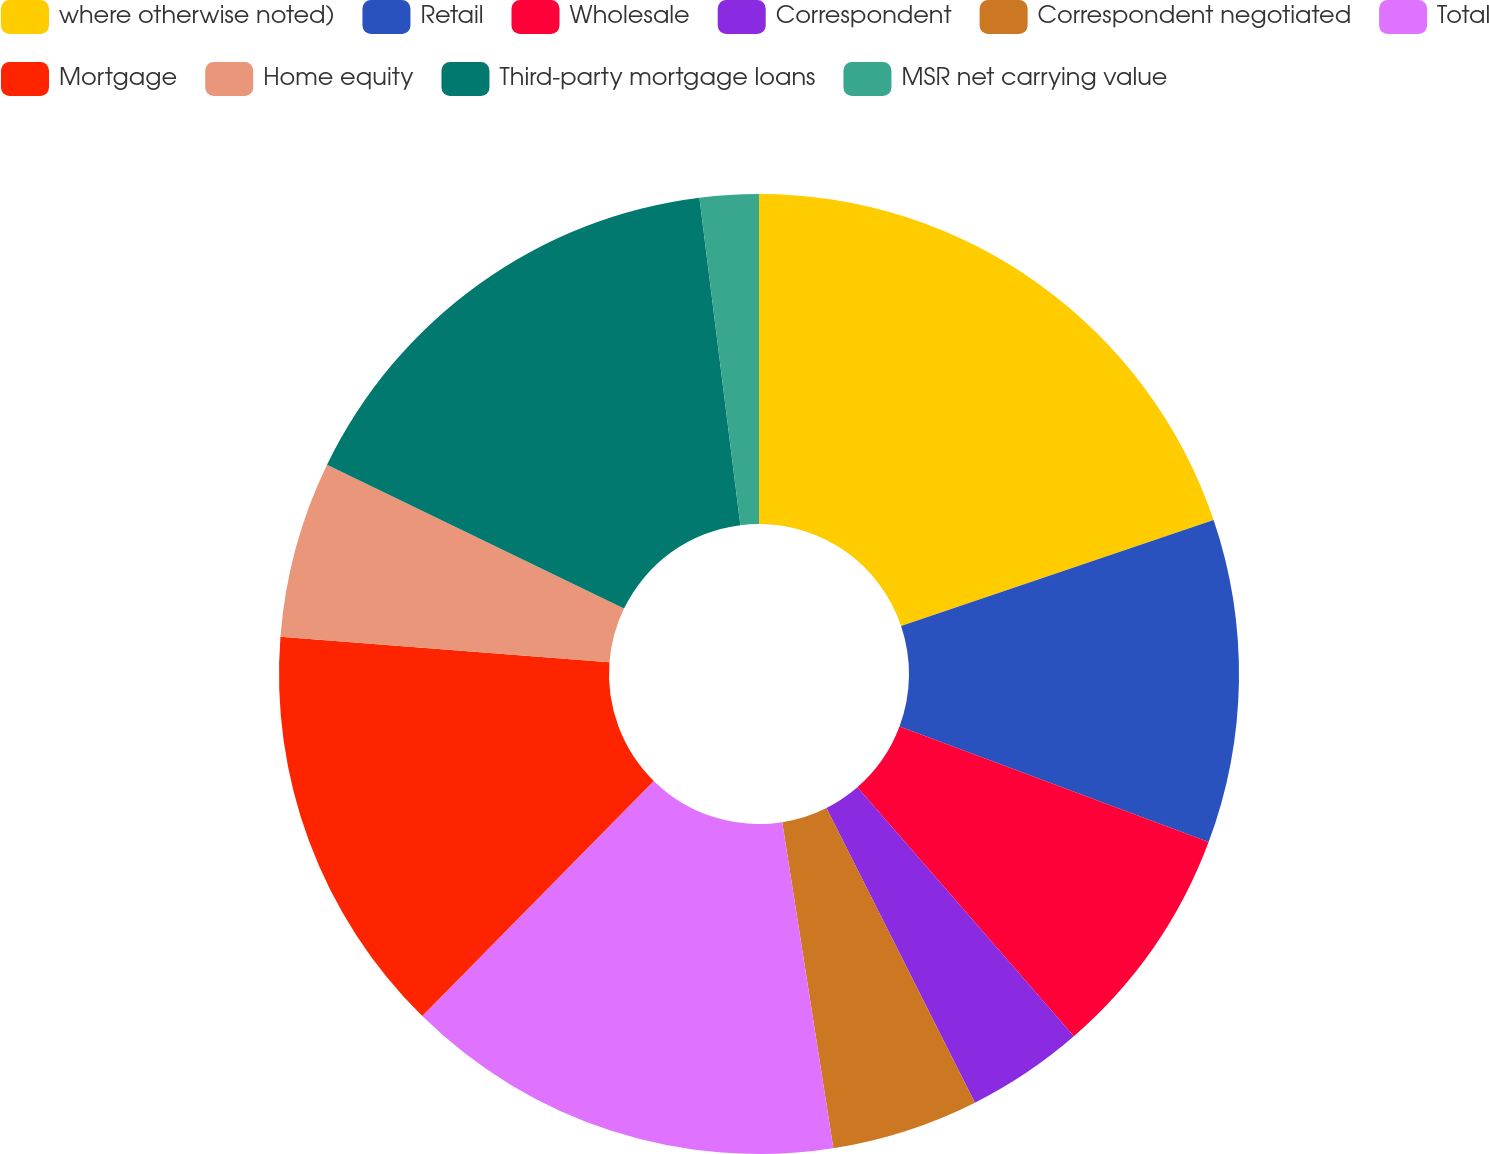Convert chart. <chart><loc_0><loc_0><loc_500><loc_500><pie_chart><fcel>where otherwise noted)<fcel>Retail<fcel>Wholesale<fcel>Correspondent<fcel>Correspondent negotiated<fcel>Total<fcel>Mortgage<fcel>Home equity<fcel>Third-party mortgage loans<fcel>MSR net carrying value<nl><fcel>19.8%<fcel>10.89%<fcel>7.92%<fcel>3.96%<fcel>4.95%<fcel>14.85%<fcel>13.86%<fcel>5.94%<fcel>15.84%<fcel>1.98%<nl></chart> 